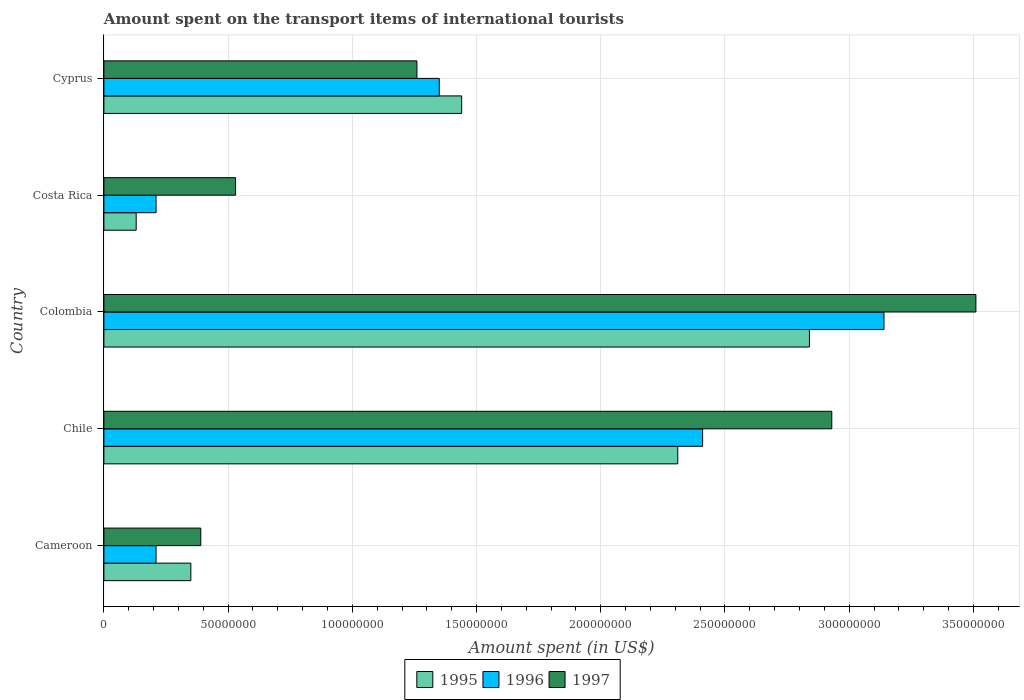How many different coloured bars are there?
Keep it short and to the point. 3. Are the number of bars per tick equal to the number of legend labels?
Offer a terse response. Yes. Are the number of bars on each tick of the Y-axis equal?
Your answer should be very brief. Yes. How many bars are there on the 3rd tick from the top?
Your answer should be compact. 3. What is the label of the 2nd group of bars from the top?
Provide a short and direct response. Costa Rica. In how many cases, is the number of bars for a given country not equal to the number of legend labels?
Offer a terse response. 0. What is the amount spent on the transport items of international tourists in 1997 in Colombia?
Make the answer very short. 3.51e+08. Across all countries, what is the maximum amount spent on the transport items of international tourists in 1997?
Your answer should be very brief. 3.51e+08. Across all countries, what is the minimum amount spent on the transport items of international tourists in 1996?
Your answer should be compact. 2.10e+07. In which country was the amount spent on the transport items of international tourists in 1997 minimum?
Offer a very short reply. Cameroon. What is the total amount spent on the transport items of international tourists in 1996 in the graph?
Your answer should be compact. 7.32e+08. What is the difference between the amount spent on the transport items of international tourists in 1995 in Cameroon and that in Cyprus?
Give a very brief answer. -1.09e+08. What is the difference between the amount spent on the transport items of international tourists in 1996 in Cyprus and the amount spent on the transport items of international tourists in 1997 in Costa Rica?
Give a very brief answer. 8.20e+07. What is the average amount spent on the transport items of international tourists in 1995 per country?
Provide a succinct answer. 1.41e+08. What is the difference between the amount spent on the transport items of international tourists in 1995 and amount spent on the transport items of international tourists in 1996 in Colombia?
Offer a very short reply. -3.00e+07. What is the ratio of the amount spent on the transport items of international tourists in 1995 in Costa Rica to that in Cyprus?
Give a very brief answer. 0.09. Is the difference between the amount spent on the transport items of international tourists in 1995 in Chile and Colombia greater than the difference between the amount spent on the transport items of international tourists in 1996 in Chile and Colombia?
Offer a terse response. Yes. What is the difference between the highest and the second highest amount spent on the transport items of international tourists in 1997?
Ensure brevity in your answer.  5.80e+07. What is the difference between the highest and the lowest amount spent on the transport items of international tourists in 1996?
Your response must be concise. 2.93e+08. Is the sum of the amount spent on the transport items of international tourists in 1997 in Cameroon and Cyprus greater than the maximum amount spent on the transport items of international tourists in 1996 across all countries?
Offer a very short reply. No. What does the 3rd bar from the top in Costa Rica represents?
Provide a short and direct response. 1995. Are all the bars in the graph horizontal?
Offer a terse response. Yes. How many countries are there in the graph?
Your answer should be very brief. 5. Are the values on the major ticks of X-axis written in scientific E-notation?
Provide a short and direct response. No. How many legend labels are there?
Make the answer very short. 3. What is the title of the graph?
Offer a terse response. Amount spent on the transport items of international tourists. What is the label or title of the X-axis?
Provide a succinct answer. Amount spent (in US$). What is the label or title of the Y-axis?
Provide a short and direct response. Country. What is the Amount spent (in US$) in 1995 in Cameroon?
Keep it short and to the point. 3.50e+07. What is the Amount spent (in US$) in 1996 in Cameroon?
Provide a short and direct response. 2.10e+07. What is the Amount spent (in US$) in 1997 in Cameroon?
Offer a terse response. 3.90e+07. What is the Amount spent (in US$) in 1995 in Chile?
Give a very brief answer. 2.31e+08. What is the Amount spent (in US$) in 1996 in Chile?
Give a very brief answer. 2.41e+08. What is the Amount spent (in US$) of 1997 in Chile?
Offer a terse response. 2.93e+08. What is the Amount spent (in US$) of 1995 in Colombia?
Provide a succinct answer. 2.84e+08. What is the Amount spent (in US$) in 1996 in Colombia?
Your answer should be very brief. 3.14e+08. What is the Amount spent (in US$) of 1997 in Colombia?
Give a very brief answer. 3.51e+08. What is the Amount spent (in US$) of 1995 in Costa Rica?
Keep it short and to the point. 1.30e+07. What is the Amount spent (in US$) of 1996 in Costa Rica?
Offer a terse response. 2.10e+07. What is the Amount spent (in US$) of 1997 in Costa Rica?
Offer a very short reply. 5.30e+07. What is the Amount spent (in US$) of 1995 in Cyprus?
Your response must be concise. 1.44e+08. What is the Amount spent (in US$) in 1996 in Cyprus?
Your response must be concise. 1.35e+08. What is the Amount spent (in US$) in 1997 in Cyprus?
Ensure brevity in your answer.  1.26e+08. Across all countries, what is the maximum Amount spent (in US$) of 1995?
Provide a succinct answer. 2.84e+08. Across all countries, what is the maximum Amount spent (in US$) in 1996?
Your answer should be compact. 3.14e+08. Across all countries, what is the maximum Amount spent (in US$) of 1997?
Give a very brief answer. 3.51e+08. Across all countries, what is the minimum Amount spent (in US$) in 1995?
Offer a very short reply. 1.30e+07. Across all countries, what is the minimum Amount spent (in US$) in 1996?
Your answer should be compact. 2.10e+07. Across all countries, what is the minimum Amount spent (in US$) of 1997?
Keep it short and to the point. 3.90e+07. What is the total Amount spent (in US$) in 1995 in the graph?
Make the answer very short. 7.07e+08. What is the total Amount spent (in US$) in 1996 in the graph?
Provide a short and direct response. 7.32e+08. What is the total Amount spent (in US$) in 1997 in the graph?
Your answer should be very brief. 8.62e+08. What is the difference between the Amount spent (in US$) of 1995 in Cameroon and that in Chile?
Give a very brief answer. -1.96e+08. What is the difference between the Amount spent (in US$) of 1996 in Cameroon and that in Chile?
Your response must be concise. -2.20e+08. What is the difference between the Amount spent (in US$) of 1997 in Cameroon and that in Chile?
Provide a succinct answer. -2.54e+08. What is the difference between the Amount spent (in US$) of 1995 in Cameroon and that in Colombia?
Make the answer very short. -2.49e+08. What is the difference between the Amount spent (in US$) in 1996 in Cameroon and that in Colombia?
Offer a terse response. -2.93e+08. What is the difference between the Amount spent (in US$) in 1997 in Cameroon and that in Colombia?
Ensure brevity in your answer.  -3.12e+08. What is the difference between the Amount spent (in US$) of 1995 in Cameroon and that in Costa Rica?
Your answer should be compact. 2.20e+07. What is the difference between the Amount spent (in US$) of 1997 in Cameroon and that in Costa Rica?
Your response must be concise. -1.40e+07. What is the difference between the Amount spent (in US$) of 1995 in Cameroon and that in Cyprus?
Ensure brevity in your answer.  -1.09e+08. What is the difference between the Amount spent (in US$) in 1996 in Cameroon and that in Cyprus?
Ensure brevity in your answer.  -1.14e+08. What is the difference between the Amount spent (in US$) in 1997 in Cameroon and that in Cyprus?
Give a very brief answer. -8.70e+07. What is the difference between the Amount spent (in US$) of 1995 in Chile and that in Colombia?
Your answer should be very brief. -5.30e+07. What is the difference between the Amount spent (in US$) in 1996 in Chile and that in Colombia?
Your response must be concise. -7.30e+07. What is the difference between the Amount spent (in US$) in 1997 in Chile and that in Colombia?
Ensure brevity in your answer.  -5.80e+07. What is the difference between the Amount spent (in US$) of 1995 in Chile and that in Costa Rica?
Keep it short and to the point. 2.18e+08. What is the difference between the Amount spent (in US$) in 1996 in Chile and that in Costa Rica?
Keep it short and to the point. 2.20e+08. What is the difference between the Amount spent (in US$) in 1997 in Chile and that in Costa Rica?
Give a very brief answer. 2.40e+08. What is the difference between the Amount spent (in US$) of 1995 in Chile and that in Cyprus?
Ensure brevity in your answer.  8.70e+07. What is the difference between the Amount spent (in US$) in 1996 in Chile and that in Cyprus?
Ensure brevity in your answer.  1.06e+08. What is the difference between the Amount spent (in US$) of 1997 in Chile and that in Cyprus?
Keep it short and to the point. 1.67e+08. What is the difference between the Amount spent (in US$) of 1995 in Colombia and that in Costa Rica?
Offer a terse response. 2.71e+08. What is the difference between the Amount spent (in US$) of 1996 in Colombia and that in Costa Rica?
Your response must be concise. 2.93e+08. What is the difference between the Amount spent (in US$) in 1997 in Colombia and that in Costa Rica?
Make the answer very short. 2.98e+08. What is the difference between the Amount spent (in US$) of 1995 in Colombia and that in Cyprus?
Offer a terse response. 1.40e+08. What is the difference between the Amount spent (in US$) in 1996 in Colombia and that in Cyprus?
Provide a succinct answer. 1.79e+08. What is the difference between the Amount spent (in US$) of 1997 in Colombia and that in Cyprus?
Provide a succinct answer. 2.25e+08. What is the difference between the Amount spent (in US$) in 1995 in Costa Rica and that in Cyprus?
Your response must be concise. -1.31e+08. What is the difference between the Amount spent (in US$) of 1996 in Costa Rica and that in Cyprus?
Provide a short and direct response. -1.14e+08. What is the difference between the Amount spent (in US$) of 1997 in Costa Rica and that in Cyprus?
Offer a very short reply. -7.30e+07. What is the difference between the Amount spent (in US$) in 1995 in Cameroon and the Amount spent (in US$) in 1996 in Chile?
Give a very brief answer. -2.06e+08. What is the difference between the Amount spent (in US$) of 1995 in Cameroon and the Amount spent (in US$) of 1997 in Chile?
Your answer should be very brief. -2.58e+08. What is the difference between the Amount spent (in US$) in 1996 in Cameroon and the Amount spent (in US$) in 1997 in Chile?
Give a very brief answer. -2.72e+08. What is the difference between the Amount spent (in US$) in 1995 in Cameroon and the Amount spent (in US$) in 1996 in Colombia?
Give a very brief answer. -2.79e+08. What is the difference between the Amount spent (in US$) in 1995 in Cameroon and the Amount spent (in US$) in 1997 in Colombia?
Your answer should be very brief. -3.16e+08. What is the difference between the Amount spent (in US$) in 1996 in Cameroon and the Amount spent (in US$) in 1997 in Colombia?
Keep it short and to the point. -3.30e+08. What is the difference between the Amount spent (in US$) in 1995 in Cameroon and the Amount spent (in US$) in 1996 in Costa Rica?
Offer a very short reply. 1.40e+07. What is the difference between the Amount spent (in US$) of 1995 in Cameroon and the Amount spent (in US$) of 1997 in Costa Rica?
Make the answer very short. -1.80e+07. What is the difference between the Amount spent (in US$) of 1996 in Cameroon and the Amount spent (in US$) of 1997 in Costa Rica?
Your answer should be very brief. -3.20e+07. What is the difference between the Amount spent (in US$) in 1995 in Cameroon and the Amount spent (in US$) in 1996 in Cyprus?
Ensure brevity in your answer.  -1.00e+08. What is the difference between the Amount spent (in US$) of 1995 in Cameroon and the Amount spent (in US$) of 1997 in Cyprus?
Give a very brief answer. -9.10e+07. What is the difference between the Amount spent (in US$) in 1996 in Cameroon and the Amount spent (in US$) in 1997 in Cyprus?
Make the answer very short. -1.05e+08. What is the difference between the Amount spent (in US$) in 1995 in Chile and the Amount spent (in US$) in 1996 in Colombia?
Your answer should be very brief. -8.30e+07. What is the difference between the Amount spent (in US$) in 1995 in Chile and the Amount spent (in US$) in 1997 in Colombia?
Your response must be concise. -1.20e+08. What is the difference between the Amount spent (in US$) in 1996 in Chile and the Amount spent (in US$) in 1997 in Colombia?
Provide a short and direct response. -1.10e+08. What is the difference between the Amount spent (in US$) in 1995 in Chile and the Amount spent (in US$) in 1996 in Costa Rica?
Make the answer very short. 2.10e+08. What is the difference between the Amount spent (in US$) in 1995 in Chile and the Amount spent (in US$) in 1997 in Costa Rica?
Keep it short and to the point. 1.78e+08. What is the difference between the Amount spent (in US$) in 1996 in Chile and the Amount spent (in US$) in 1997 in Costa Rica?
Your answer should be very brief. 1.88e+08. What is the difference between the Amount spent (in US$) in 1995 in Chile and the Amount spent (in US$) in 1996 in Cyprus?
Your answer should be compact. 9.60e+07. What is the difference between the Amount spent (in US$) in 1995 in Chile and the Amount spent (in US$) in 1997 in Cyprus?
Ensure brevity in your answer.  1.05e+08. What is the difference between the Amount spent (in US$) in 1996 in Chile and the Amount spent (in US$) in 1997 in Cyprus?
Provide a succinct answer. 1.15e+08. What is the difference between the Amount spent (in US$) in 1995 in Colombia and the Amount spent (in US$) in 1996 in Costa Rica?
Provide a short and direct response. 2.63e+08. What is the difference between the Amount spent (in US$) in 1995 in Colombia and the Amount spent (in US$) in 1997 in Costa Rica?
Offer a terse response. 2.31e+08. What is the difference between the Amount spent (in US$) in 1996 in Colombia and the Amount spent (in US$) in 1997 in Costa Rica?
Give a very brief answer. 2.61e+08. What is the difference between the Amount spent (in US$) in 1995 in Colombia and the Amount spent (in US$) in 1996 in Cyprus?
Your response must be concise. 1.49e+08. What is the difference between the Amount spent (in US$) of 1995 in Colombia and the Amount spent (in US$) of 1997 in Cyprus?
Offer a terse response. 1.58e+08. What is the difference between the Amount spent (in US$) in 1996 in Colombia and the Amount spent (in US$) in 1997 in Cyprus?
Your answer should be compact. 1.88e+08. What is the difference between the Amount spent (in US$) in 1995 in Costa Rica and the Amount spent (in US$) in 1996 in Cyprus?
Keep it short and to the point. -1.22e+08. What is the difference between the Amount spent (in US$) in 1995 in Costa Rica and the Amount spent (in US$) in 1997 in Cyprus?
Your answer should be very brief. -1.13e+08. What is the difference between the Amount spent (in US$) in 1996 in Costa Rica and the Amount spent (in US$) in 1997 in Cyprus?
Provide a succinct answer. -1.05e+08. What is the average Amount spent (in US$) of 1995 per country?
Provide a short and direct response. 1.41e+08. What is the average Amount spent (in US$) in 1996 per country?
Make the answer very short. 1.46e+08. What is the average Amount spent (in US$) in 1997 per country?
Give a very brief answer. 1.72e+08. What is the difference between the Amount spent (in US$) in 1995 and Amount spent (in US$) in 1996 in Cameroon?
Offer a terse response. 1.40e+07. What is the difference between the Amount spent (in US$) of 1996 and Amount spent (in US$) of 1997 in Cameroon?
Provide a short and direct response. -1.80e+07. What is the difference between the Amount spent (in US$) of 1995 and Amount spent (in US$) of 1996 in Chile?
Give a very brief answer. -1.00e+07. What is the difference between the Amount spent (in US$) of 1995 and Amount spent (in US$) of 1997 in Chile?
Your response must be concise. -6.20e+07. What is the difference between the Amount spent (in US$) of 1996 and Amount spent (in US$) of 1997 in Chile?
Your answer should be compact. -5.20e+07. What is the difference between the Amount spent (in US$) of 1995 and Amount spent (in US$) of 1996 in Colombia?
Keep it short and to the point. -3.00e+07. What is the difference between the Amount spent (in US$) in 1995 and Amount spent (in US$) in 1997 in Colombia?
Your response must be concise. -6.70e+07. What is the difference between the Amount spent (in US$) in 1996 and Amount spent (in US$) in 1997 in Colombia?
Ensure brevity in your answer.  -3.70e+07. What is the difference between the Amount spent (in US$) of 1995 and Amount spent (in US$) of 1996 in Costa Rica?
Give a very brief answer. -8.00e+06. What is the difference between the Amount spent (in US$) of 1995 and Amount spent (in US$) of 1997 in Costa Rica?
Provide a succinct answer. -4.00e+07. What is the difference between the Amount spent (in US$) in 1996 and Amount spent (in US$) in 1997 in Costa Rica?
Offer a terse response. -3.20e+07. What is the difference between the Amount spent (in US$) of 1995 and Amount spent (in US$) of 1996 in Cyprus?
Provide a short and direct response. 9.00e+06. What is the difference between the Amount spent (in US$) in 1995 and Amount spent (in US$) in 1997 in Cyprus?
Your answer should be very brief. 1.80e+07. What is the difference between the Amount spent (in US$) in 1996 and Amount spent (in US$) in 1997 in Cyprus?
Keep it short and to the point. 9.00e+06. What is the ratio of the Amount spent (in US$) in 1995 in Cameroon to that in Chile?
Give a very brief answer. 0.15. What is the ratio of the Amount spent (in US$) of 1996 in Cameroon to that in Chile?
Your answer should be very brief. 0.09. What is the ratio of the Amount spent (in US$) in 1997 in Cameroon to that in Chile?
Your answer should be very brief. 0.13. What is the ratio of the Amount spent (in US$) in 1995 in Cameroon to that in Colombia?
Keep it short and to the point. 0.12. What is the ratio of the Amount spent (in US$) of 1996 in Cameroon to that in Colombia?
Make the answer very short. 0.07. What is the ratio of the Amount spent (in US$) in 1997 in Cameroon to that in Colombia?
Provide a short and direct response. 0.11. What is the ratio of the Amount spent (in US$) of 1995 in Cameroon to that in Costa Rica?
Your answer should be compact. 2.69. What is the ratio of the Amount spent (in US$) of 1997 in Cameroon to that in Costa Rica?
Keep it short and to the point. 0.74. What is the ratio of the Amount spent (in US$) in 1995 in Cameroon to that in Cyprus?
Your answer should be very brief. 0.24. What is the ratio of the Amount spent (in US$) of 1996 in Cameroon to that in Cyprus?
Give a very brief answer. 0.16. What is the ratio of the Amount spent (in US$) in 1997 in Cameroon to that in Cyprus?
Your answer should be very brief. 0.31. What is the ratio of the Amount spent (in US$) in 1995 in Chile to that in Colombia?
Offer a terse response. 0.81. What is the ratio of the Amount spent (in US$) in 1996 in Chile to that in Colombia?
Make the answer very short. 0.77. What is the ratio of the Amount spent (in US$) in 1997 in Chile to that in Colombia?
Give a very brief answer. 0.83. What is the ratio of the Amount spent (in US$) in 1995 in Chile to that in Costa Rica?
Your response must be concise. 17.77. What is the ratio of the Amount spent (in US$) in 1996 in Chile to that in Costa Rica?
Offer a terse response. 11.48. What is the ratio of the Amount spent (in US$) of 1997 in Chile to that in Costa Rica?
Keep it short and to the point. 5.53. What is the ratio of the Amount spent (in US$) in 1995 in Chile to that in Cyprus?
Provide a succinct answer. 1.6. What is the ratio of the Amount spent (in US$) in 1996 in Chile to that in Cyprus?
Your answer should be very brief. 1.79. What is the ratio of the Amount spent (in US$) of 1997 in Chile to that in Cyprus?
Give a very brief answer. 2.33. What is the ratio of the Amount spent (in US$) in 1995 in Colombia to that in Costa Rica?
Your response must be concise. 21.85. What is the ratio of the Amount spent (in US$) of 1996 in Colombia to that in Costa Rica?
Your response must be concise. 14.95. What is the ratio of the Amount spent (in US$) of 1997 in Colombia to that in Costa Rica?
Provide a short and direct response. 6.62. What is the ratio of the Amount spent (in US$) in 1995 in Colombia to that in Cyprus?
Offer a terse response. 1.97. What is the ratio of the Amount spent (in US$) in 1996 in Colombia to that in Cyprus?
Your answer should be very brief. 2.33. What is the ratio of the Amount spent (in US$) in 1997 in Colombia to that in Cyprus?
Ensure brevity in your answer.  2.79. What is the ratio of the Amount spent (in US$) of 1995 in Costa Rica to that in Cyprus?
Ensure brevity in your answer.  0.09. What is the ratio of the Amount spent (in US$) in 1996 in Costa Rica to that in Cyprus?
Your response must be concise. 0.16. What is the ratio of the Amount spent (in US$) in 1997 in Costa Rica to that in Cyprus?
Your answer should be very brief. 0.42. What is the difference between the highest and the second highest Amount spent (in US$) of 1995?
Your response must be concise. 5.30e+07. What is the difference between the highest and the second highest Amount spent (in US$) of 1996?
Make the answer very short. 7.30e+07. What is the difference between the highest and the second highest Amount spent (in US$) in 1997?
Keep it short and to the point. 5.80e+07. What is the difference between the highest and the lowest Amount spent (in US$) of 1995?
Keep it short and to the point. 2.71e+08. What is the difference between the highest and the lowest Amount spent (in US$) of 1996?
Your answer should be very brief. 2.93e+08. What is the difference between the highest and the lowest Amount spent (in US$) in 1997?
Make the answer very short. 3.12e+08. 